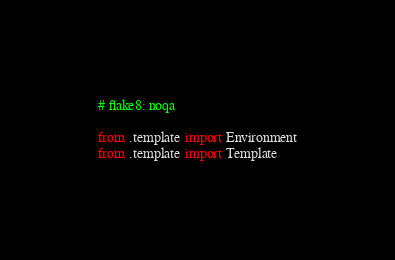Convert code to text. <code><loc_0><loc_0><loc_500><loc_500><_Python_># flake8: noqa

from .template import Environment
from .template import Template
</code> 